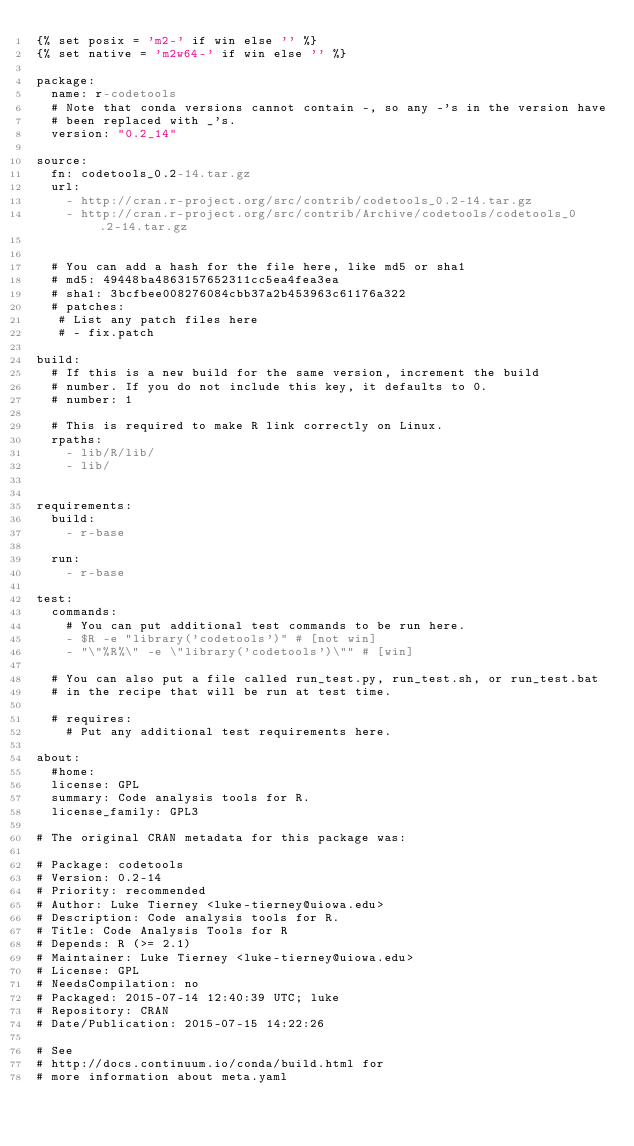<code> <loc_0><loc_0><loc_500><loc_500><_YAML_>{% set posix = 'm2-' if win else '' %}
{% set native = 'm2w64-' if win else '' %}

package:
  name: r-codetools
  # Note that conda versions cannot contain -, so any -'s in the version have
  # been replaced with _'s.
  version: "0.2_14"

source:
  fn: codetools_0.2-14.tar.gz
  url:
    - http://cran.r-project.org/src/contrib/codetools_0.2-14.tar.gz
    - http://cran.r-project.org/src/contrib/Archive/codetools/codetools_0.2-14.tar.gz


  # You can add a hash for the file here, like md5 or sha1
  # md5: 49448ba4863157652311cc5ea4fea3ea
  # sha1: 3bcfbee008276084cbb37a2b453963c61176a322
  # patches:
   # List any patch files here
   # - fix.patch

build:
  # If this is a new build for the same version, increment the build
  # number. If you do not include this key, it defaults to 0.
  # number: 1

  # This is required to make R link correctly on Linux.
  rpaths:
    - lib/R/lib/
    - lib/


requirements:
  build:
    - r-base

  run:
    - r-base

test:
  commands:
    # You can put additional test commands to be run here.
    - $R -e "library('codetools')" # [not win]
    - "\"%R%\" -e \"library('codetools')\"" # [win]

  # You can also put a file called run_test.py, run_test.sh, or run_test.bat
  # in the recipe that will be run at test time.

  # requires:
    # Put any additional test requirements here.

about:
  #home:
  license: GPL
  summary: Code analysis tools for R.
  license_family: GPL3

# The original CRAN metadata for this package was:

# Package: codetools
# Version: 0.2-14
# Priority: recommended
# Author: Luke Tierney <luke-tierney@uiowa.edu>
# Description: Code analysis tools for R.
# Title: Code Analysis Tools for R
# Depends: R (>= 2.1)
# Maintainer: Luke Tierney <luke-tierney@uiowa.edu>
# License: GPL
# NeedsCompilation: no
# Packaged: 2015-07-14 12:40:39 UTC; luke
# Repository: CRAN
# Date/Publication: 2015-07-15 14:22:26

# See
# http://docs.continuum.io/conda/build.html for
# more information about meta.yaml
</code> 